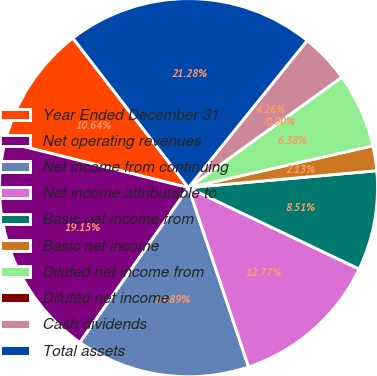Convert chart to OTSL. <chart><loc_0><loc_0><loc_500><loc_500><pie_chart><fcel>Year Ended December 31<fcel>Net operating revenues<fcel>Net income from continuing<fcel>Net income attributable to<fcel>Basic net income from<fcel>Basic net income<fcel>Diluted net income from<fcel>Diluted net income<fcel>Cash dividends<fcel>Total assets<nl><fcel>10.64%<fcel>19.15%<fcel>14.89%<fcel>12.77%<fcel>8.51%<fcel>2.13%<fcel>6.38%<fcel>0.0%<fcel>4.26%<fcel>21.28%<nl></chart> 